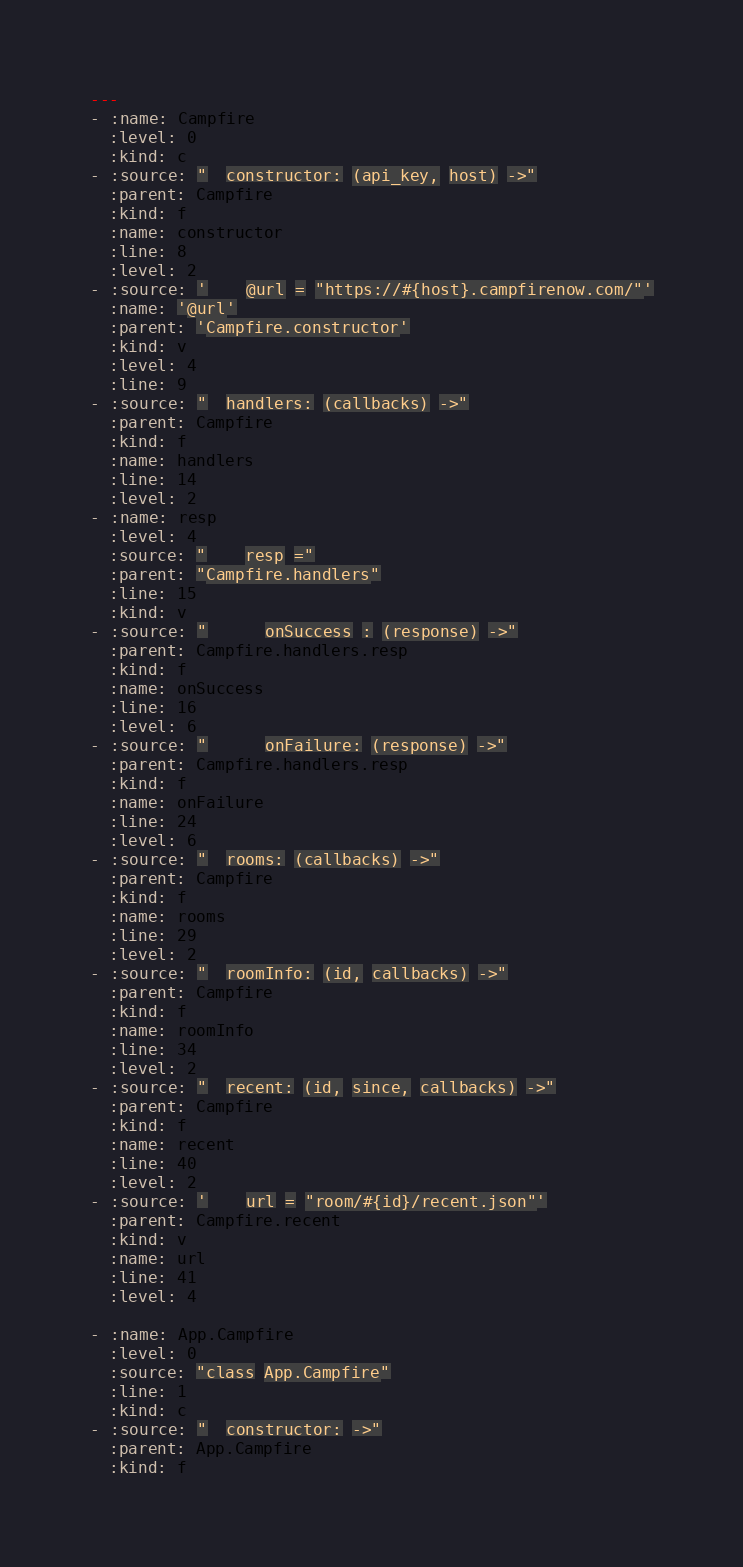<code> <loc_0><loc_0><loc_500><loc_500><_YAML_>---
- :name: Campfire
  :level: 0
  :kind: c
- :source: "  constructor: (api_key, host) ->"
  :parent: Campfire
  :kind: f
  :name: constructor
  :line: 8
  :level: 2
- :source: '    @url = "https://#{host}.campfirenow.com/"'
  :name: '@url'
  :parent: 'Campfire.constructor'
  :kind: v
  :level: 4
  :line: 9
- :source: "  handlers: (callbacks) ->"
  :parent: Campfire
  :kind: f
  :name: handlers
  :line: 14
  :level: 2
- :name: resp
  :level: 4
  :source: "    resp ="
  :parent: "Campfire.handlers"
  :line: 15
  :kind: v
- :source: "      onSuccess : (response) ->"
  :parent: Campfire.handlers.resp
  :kind: f
  :name: onSuccess
  :line: 16
  :level: 6
- :source: "      onFailure: (response) ->"
  :parent: Campfire.handlers.resp
  :kind: f
  :name: onFailure
  :line: 24
  :level: 6
- :source: "  rooms: (callbacks) ->"
  :parent: Campfire
  :kind: f
  :name: rooms
  :line: 29
  :level: 2
- :source: "  roomInfo: (id, callbacks) ->"
  :parent: Campfire
  :kind: f
  :name: roomInfo
  :line: 34
  :level: 2
- :source: "  recent: (id, since, callbacks) ->"
  :parent: Campfire
  :kind: f
  :name: recent
  :line: 40
  :level: 2
- :source: '    url = "room/#{id}/recent.json"'
  :parent: Campfire.recent
  :kind: v
  :name: url
  :line: 41
  :level: 4

- :name: App.Campfire
  :level: 0
  :source: "class App.Campfire"
  :line: 1
  :kind: c
- :source: "  constructor: ->"
  :parent: App.Campfire
  :kind: f</code> 